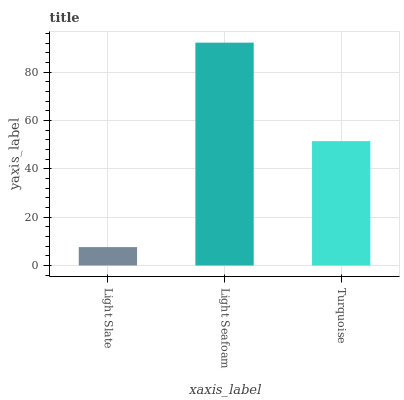Is Light Slate the minimum?
Answer yes or no. Yes. Is Light Seafoam the maximum?
Answer yes or no. Yes. Is Turquoise the minimum?
Answer yes or no. No. Is Turquoise the maximum?
Answer yes or no. No. Is Light Seafoam greater than Turquoise?
Answer yes or no. Yes. Is Turquoise less than Light Seafoam?
Answer yes or no. Yes. Is Turquoise greater than Light Seafoam?
Answer yes or no. No. Is Light Seafoam less than Turquoise?
Answer yes or no. No. Is Turquoise the high median?
Answer yes or no. Yes. Is Turquoise the low median?
Answer yes or no. Yes. Is Light Seafoam the high median?
Answer yes or no. No. Is Light Seafoam the low median?
Answer yes or no. No. 